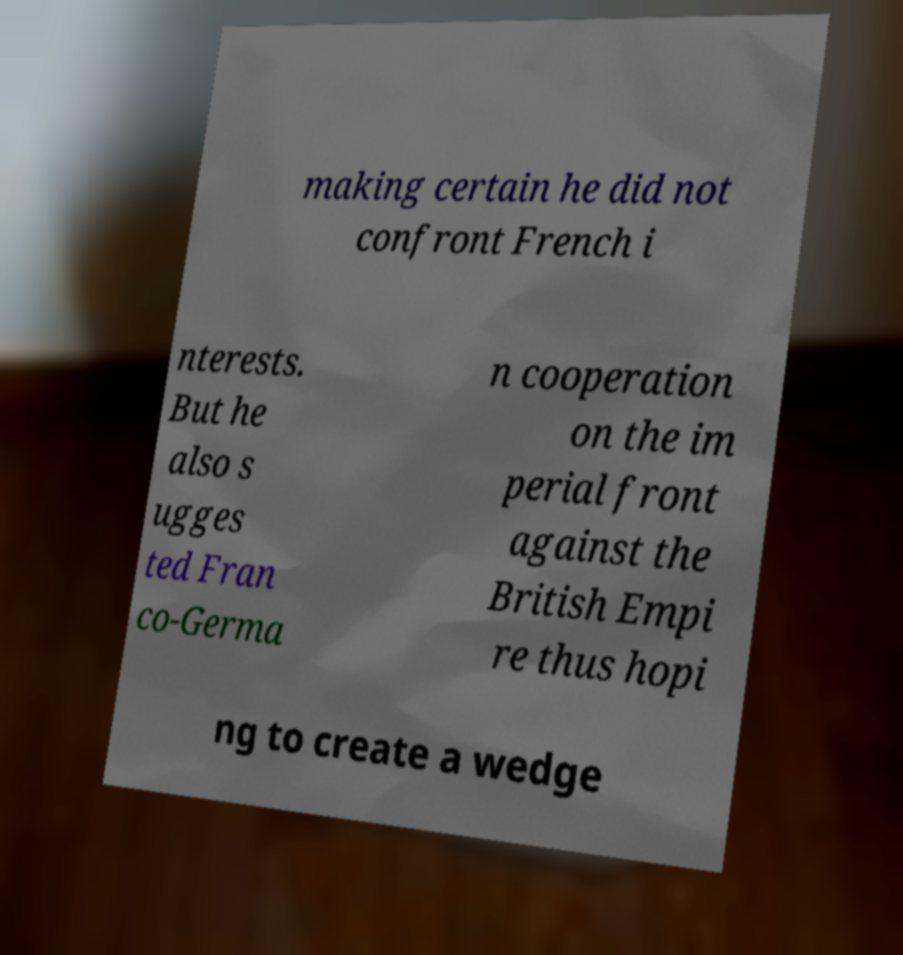There's text embedded in this image that I need extracted. Can you transcribe it verbatim? making certain he did not confront French i nterests. But he also s ugges ted Fran co-Germa n cooperation on the im perial front against the British Empi re thus hopi ng to create a wedge 